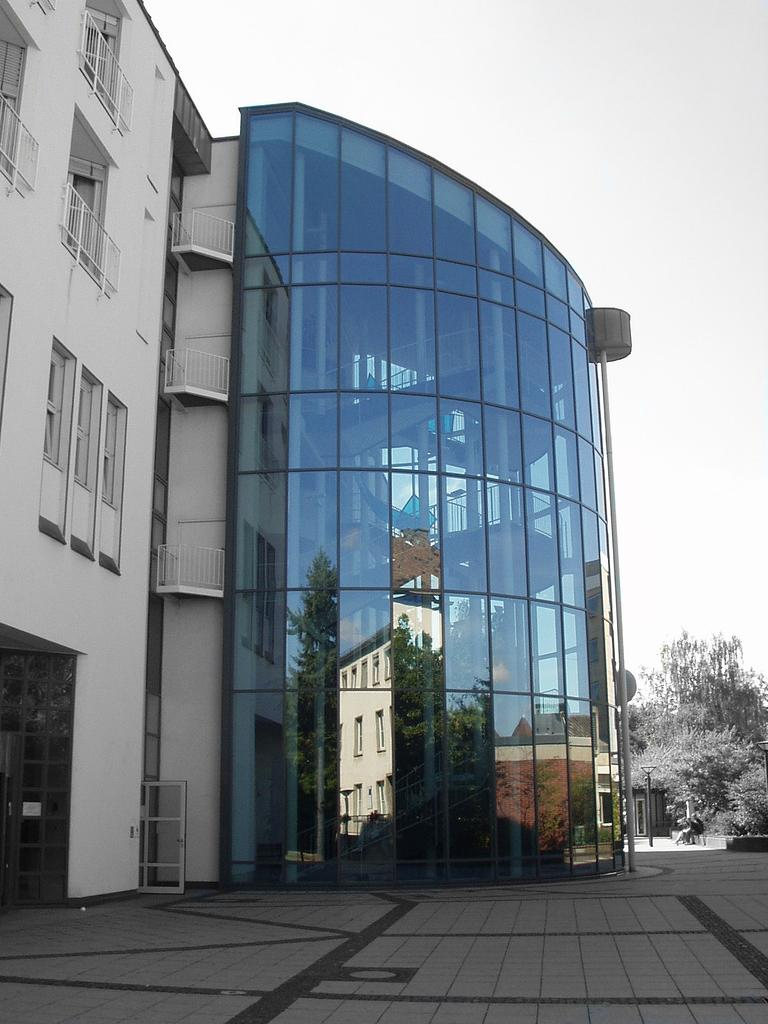What is the main subject of the image? The main subject of the image is a building. What is unique about the building's appearance? The building has a glass covering. What can be seen in the background of the image? There are trees in the background of the image. What is visible at the bottom of the image? There is a floor visible at the bottom of the image. What is the income of the person who designed the building in the image? There is no information about the designer's income in the image, as it only shows the building itself. 